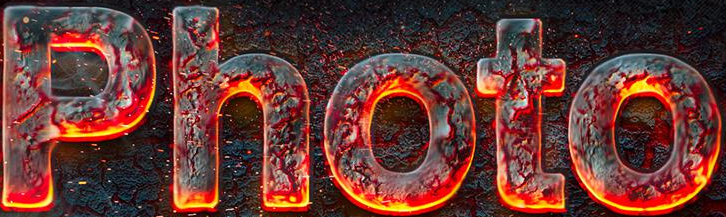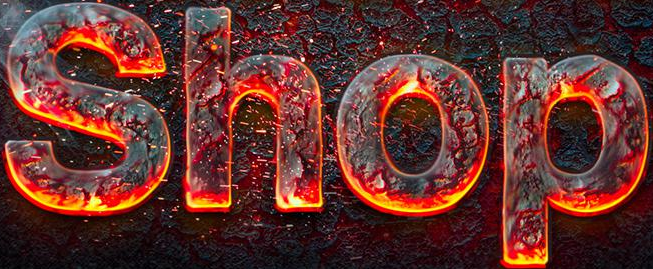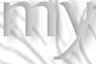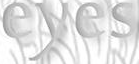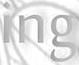What words are shown in these images in order, separated by a semicolon? Photo; Shop; my; eyes; ing 